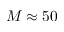<formula> <loc_0><loc_0><loc_500><loc_500>M \approx 5 0</formula> 